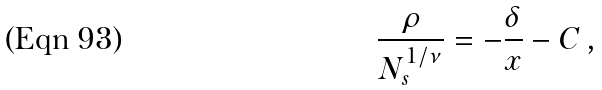<formula> <loc_0><loc_0><loc_500><loc_500>\frac { \rho } { N _ { s } ^ { 1 / \nu } } = - \frac { \delta } { x } - C \, ,</formula> 